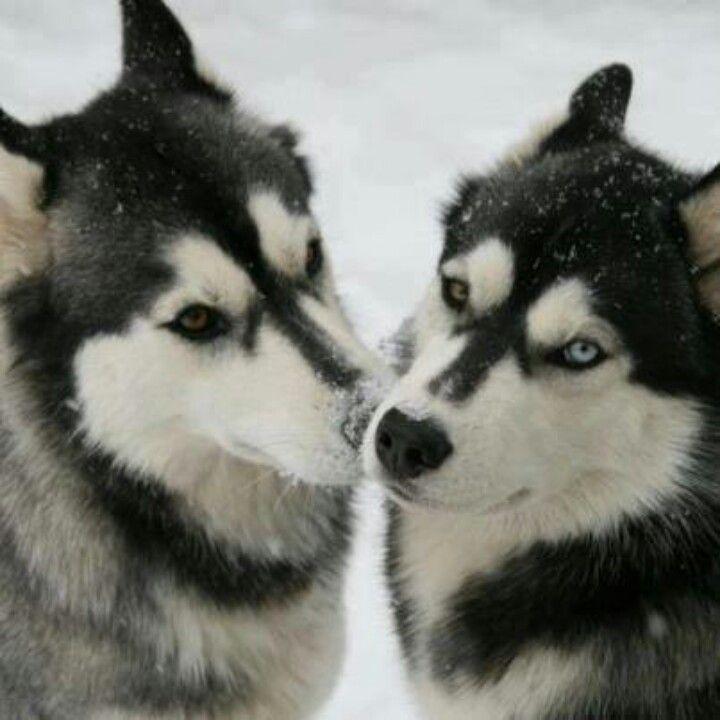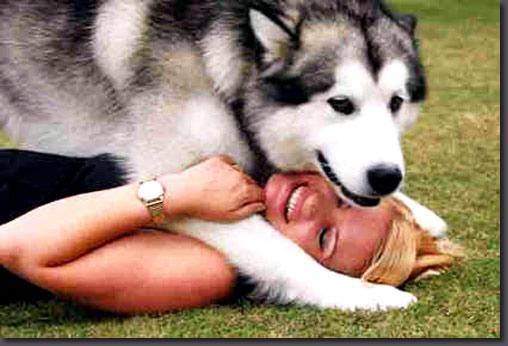The first image is the image on the left, the second image is the image on the right. Examine the images to the left and right. Is the description "One image shows two 'real' husky dogs posed face-to-face with noses close together and snow on some fur, and the other image includes one dog with its body turned rightward." accurate? Answer yes or no. Yes. The first image is the image on the left, the second image is the image on the right. Evaluate the accuracy of this statement regarding the images: "Two of the huskies are touching faces with each other in snowy weather.". Is it true? Answer yes or no. Yes. 